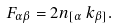<formula> <loc_0><loc_0><loc_500><loc_500>F _ { \alpha \beta } = 2 n _ { [ \alpha } \, k _ { \beta ] } .</formula> 